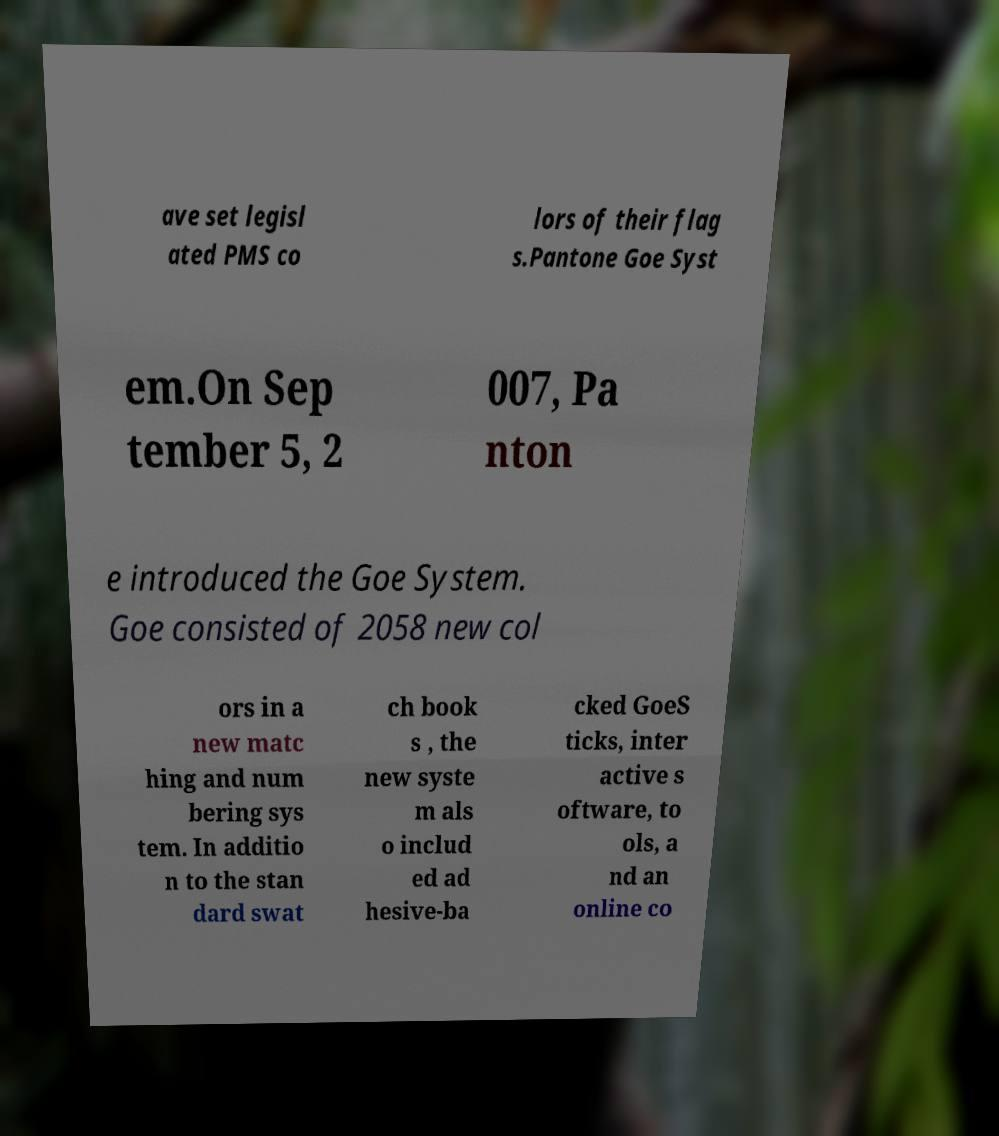For documentation purposes, I need the text within this image transcribed. Could you provide that? ave set legisl ated PMS co lors of their flag s.Pantone Goe Syst em.On Sep tember 5, 2 007, Pa nton e introduced the Goe System. Goe consisted of 2058 new col ors in a new matc hing and num bering sys tem. In additio n to the stan dard swat ch book s , the new syste m als o includ ed ad hesive-ba cked GoeS ticks, inter active s oftware, to ols, a nd an online co 